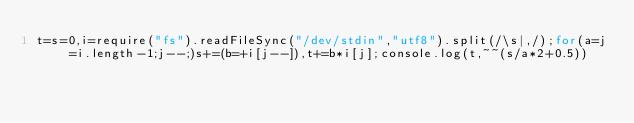<code> <loc_0><loc_0><loc_500><loc_500><_JavaScript_>t=s=0,i=require("fs").readFileSync("/dev/stdin","utf8").split(/\s|,/);for(a=j=i.length-1;j--;)s+=(b=+i[j--]),t+=b*i[j];console.log(t,~~(s/a*2+0.5))</code> 